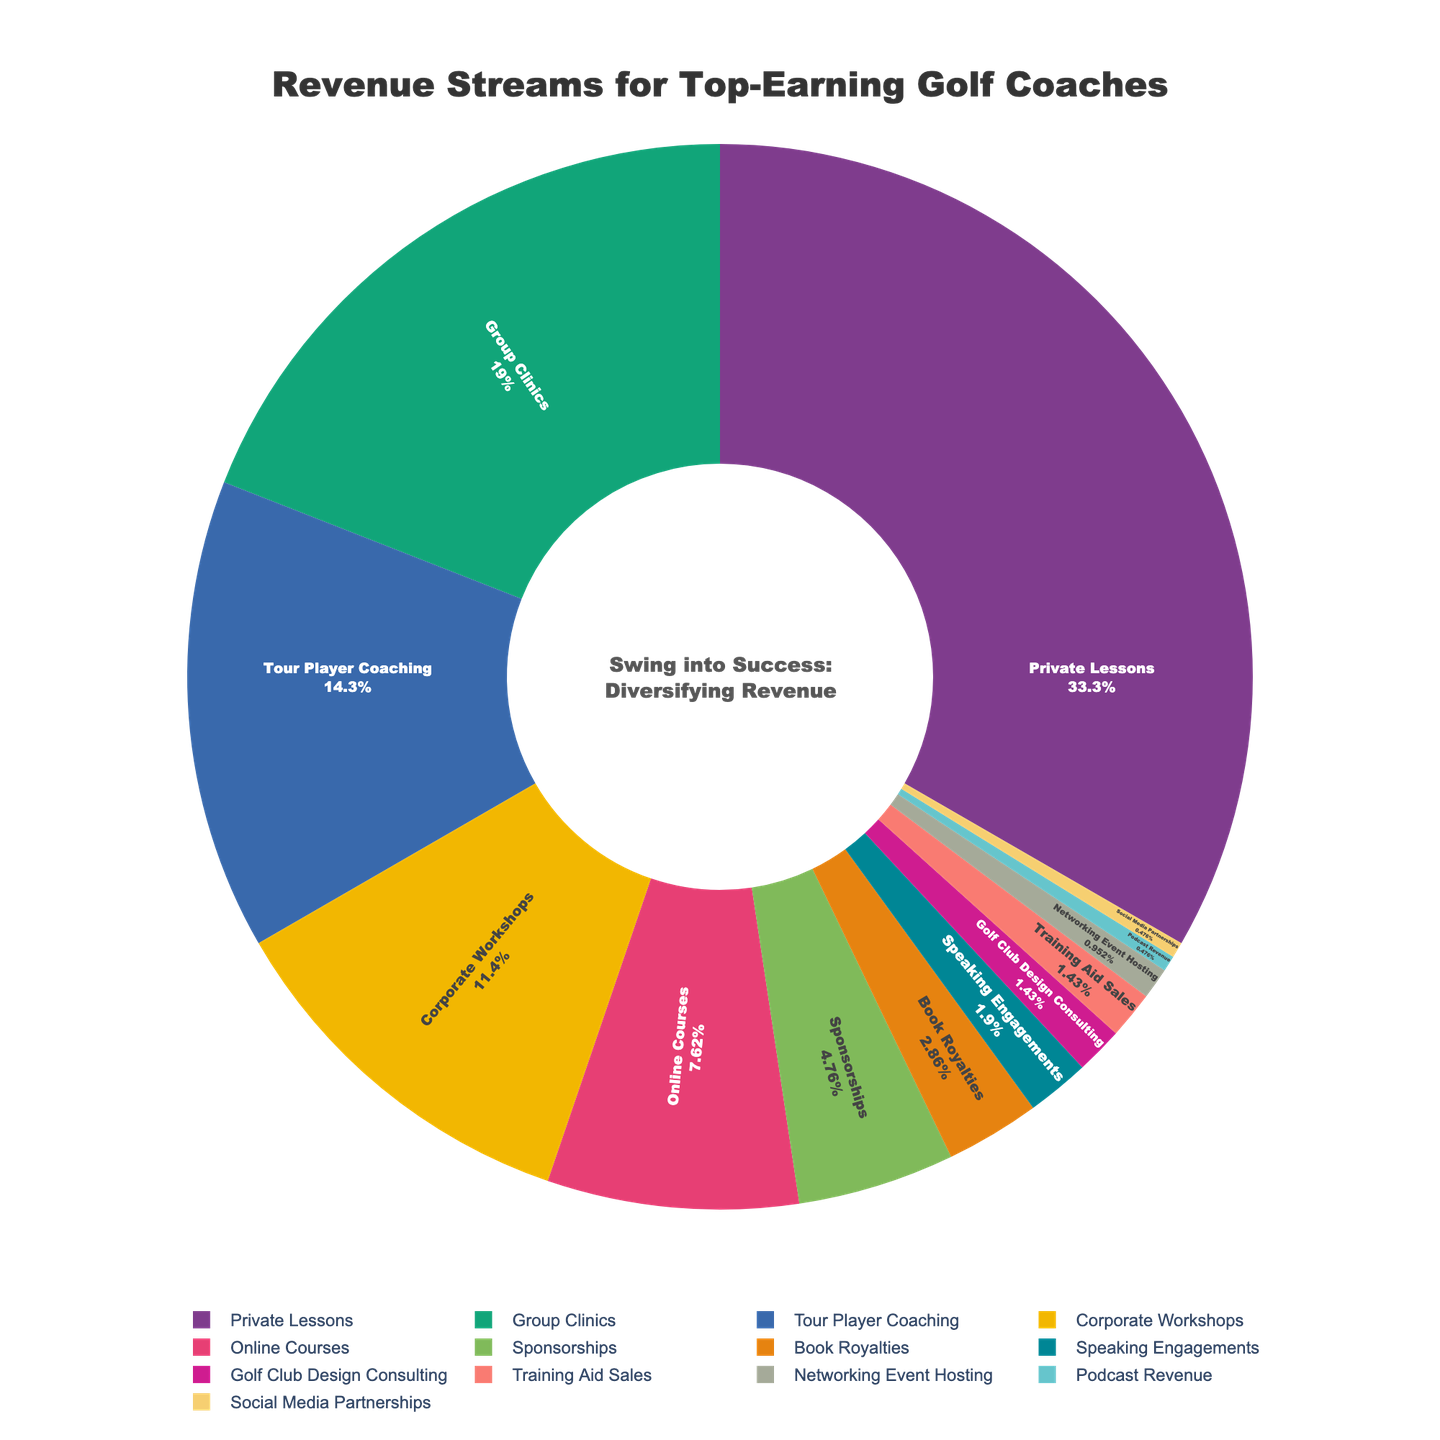Which revenue stream contributes the most to the total revenue for top-earning golf coaches? The largest segment in the pie chart is labeled "Private Lessons," accounting for 35%.
Answer: Private Lessons Which revenue streams make up more than 10% of the total revenue? The segments labeled "Private Lessons" (35%), "Group Clinics" (20%), "Tour Player Coaching" (15%), and "Corporate Workshops" (12%) all individually account for more than 10% of the total revenue.
Answer: Private Lessons, Group Clinics, Tour Player Coaching, Corporate Workshops How much percentage do the top three revenue streams contribute to the total revenue? The top three revenue streams are "Private Lessons" (35%), "Group Clinics" (20%), and "Tour Player Coaching" (15%). Adding these percentages gives 35% + 20% + 15% = 70%.
Answer: 70% Which revenue stream contributes the least to the total revenue for top-earning golf coaches? The smallest segment in the pie chart is labeled "Social Media Partnerships," accounting for 0.5%.
Answer: Social Media Partnerships Compare the revenue generated from online courses to that from corporate workshops. The segment for "Online Courses" accounts for 8% while "Corporate Workshops" accounts for 12%. Corporate Workshops contribute more.
Answer: Corporate Workshops contribute more How does the percentage of revenue from sponsorships compare to that from book royalties? The segment for "Sponsorships" accounts for 5% and "Book Royalties" accounts for 3%. Sponsorships contribute a larger percentage.
Answer: Sponsorships How much more percentage does private lessons contribute compared to group clinics? "Private Lessons" contribute 35% and "Group Clinics" contribute 20%. The difference is 35% - 20% = 15%.
Answer: 15% What is the combined percentage of revenue from training aid sales and golf club design consulting? The segments are 1.5% for Training Aid Sales and 1.5% for Golf Club Design Consulting. Adding these gives 1.5% + 1.5% = 3%.
Answer: 3% Which color represents the segment for tour player coaching? The specific color is not provided, but it should be consistent with the provided color palette in the pie chart. Look for the label "Tour Player Coaching" to identify the color.
Answer: Check the chart for the color labeled "Tour Player Coaching" What is the combined percentage of all revenue streams that individually contribute less than 5%? The segments contributing less than 5% are "Book Royalties" (3%), "Speaking Engagements" (2%), "Golf Club Design Consulting" (1.5%), "Training Aid Sales" (1.5%), "Networking Event Hosting" (1%), "Podcast Revenue" (0.5%), and "Social Media Partnerships" (0.5%). Adding these gives 3% + 2% + 1.5% + 1.5% + 1% + 0.5% + 0.5% = 10%.
Answer: 10% 